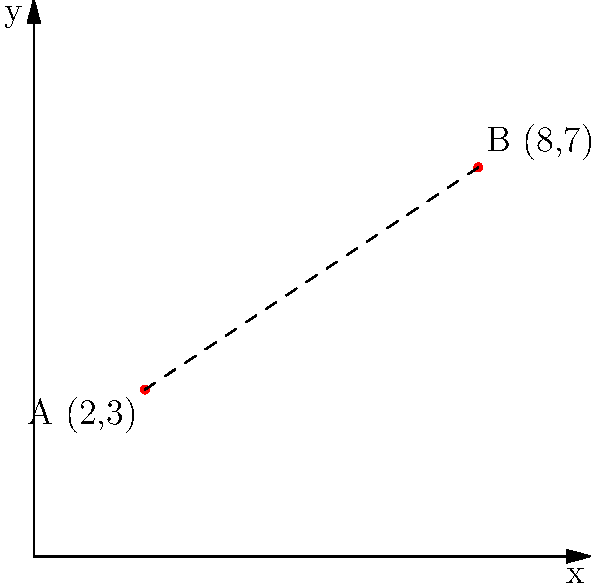As an event coordinator, you need to calculate the distance between two hydration stations on the race course. Station A is located at coordinates (2,3) and Station B is at (8,7). Using the distance formula, determine the distance between these two stations to ensure proper spacing for runner support. To calculate the distance between two points in a coordinate system, we use the distance formula:

$$d = \sqrt{(x_2 - x_1)^2 + (y_2 - y_1)^2}$$

Where $(x_1, y_1)$ represents the coordinates of the first point and $(x_2, y_2)$ represents the coordinates of the second point.

Given:
- Station A: $(x_1, y_1) = (2, 3)$
- Station B: $(x_2, y_2) = (8, 7)$

Step 1: Substitute the values into the formula:
$$d = \sqrt{(8 - 2)^2 + (7 - 3)^2}$$

Step 2: Simplify the expressions inside the parentheses:
$$d = \sqrt{6^2 + 4^2}$$

Step 3: Calculate the squares:
$$d = \sqrt{36 + 16}$$

Step 4: Add the values under the square root:
$$d = \sqrt{52}$$

Step 5: Simplify the square root:
$$d = 2\sqrt{13}$$

Therefore, the distance between the two hydration stations is $2\sqrt{13}$ units.
Answer: $2\sqrt{13}$ units 